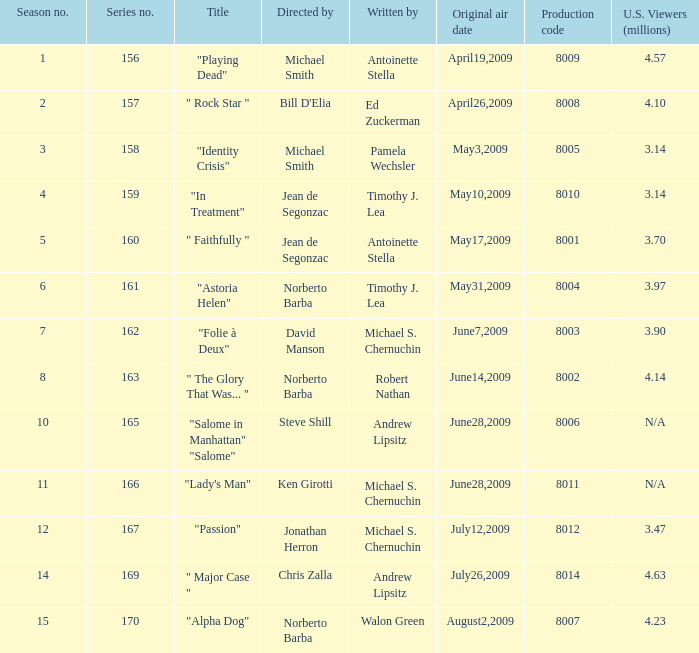Which is the  maximun serie episode number when the millions of north american spectators is 3.14? 159.0. 